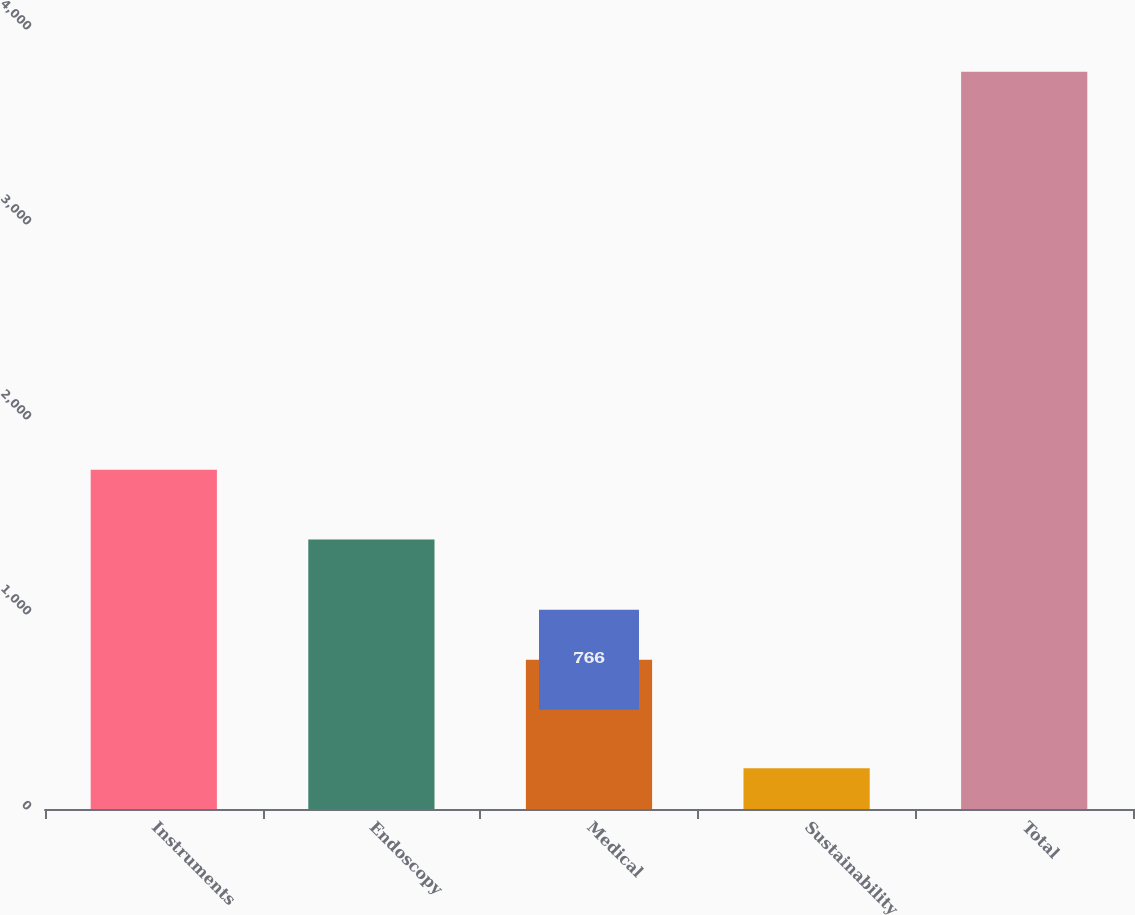<chart> <loc_0><loc_0><loc_500><loc_500><bar_chart><fcel>Instruments<fcel>Endoscopy<fcel>Medical<fcel>Sustainability<fcel>Total<nl><fcel>1739.2<fcel>1382<fcel>766<fcel>209<fcel>3781<nl></chart> 